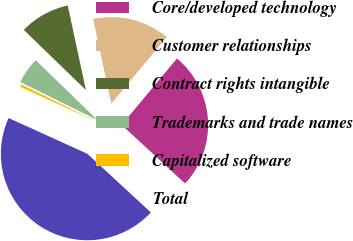<chart> <loc_0><loc_0><loc_500><loc_500><pie_chart><fcel>Core/developed technology<fcel>Customer relationships<fcel>Contract rights intangible<fcel>Trademarks and trade names<fcel>Capitalized software<fcel>Total<nl><fcel>25.81%<fcel>14.42%<fcel>9.39%<fcel>4.95%<fcel>0.51%<fcel>44.93%<nl></chart> 